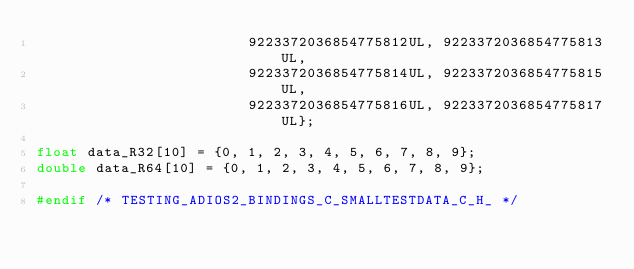<code> <loc_0><loc_0><loc_500><loc_500><_C_>                         9223372036854775812UL, 9223372036854775813UL,
                         9223372036854775814UL, 9223372036854775815UL,
                         9223372036854775816UL, 9223372036854775817UL};

float data_R32[10] = {0, 1, 2, 3, 4, 5, 6, 7, 8, 9};
double data_R64[10] = {0, 1, 2, 3, 4, 5, 6, 7, 8, 9};

#endif /* TESTING_ADIOS2_BINDINGS_C_SMALLTESTDATA_C_H_ */
</code> 